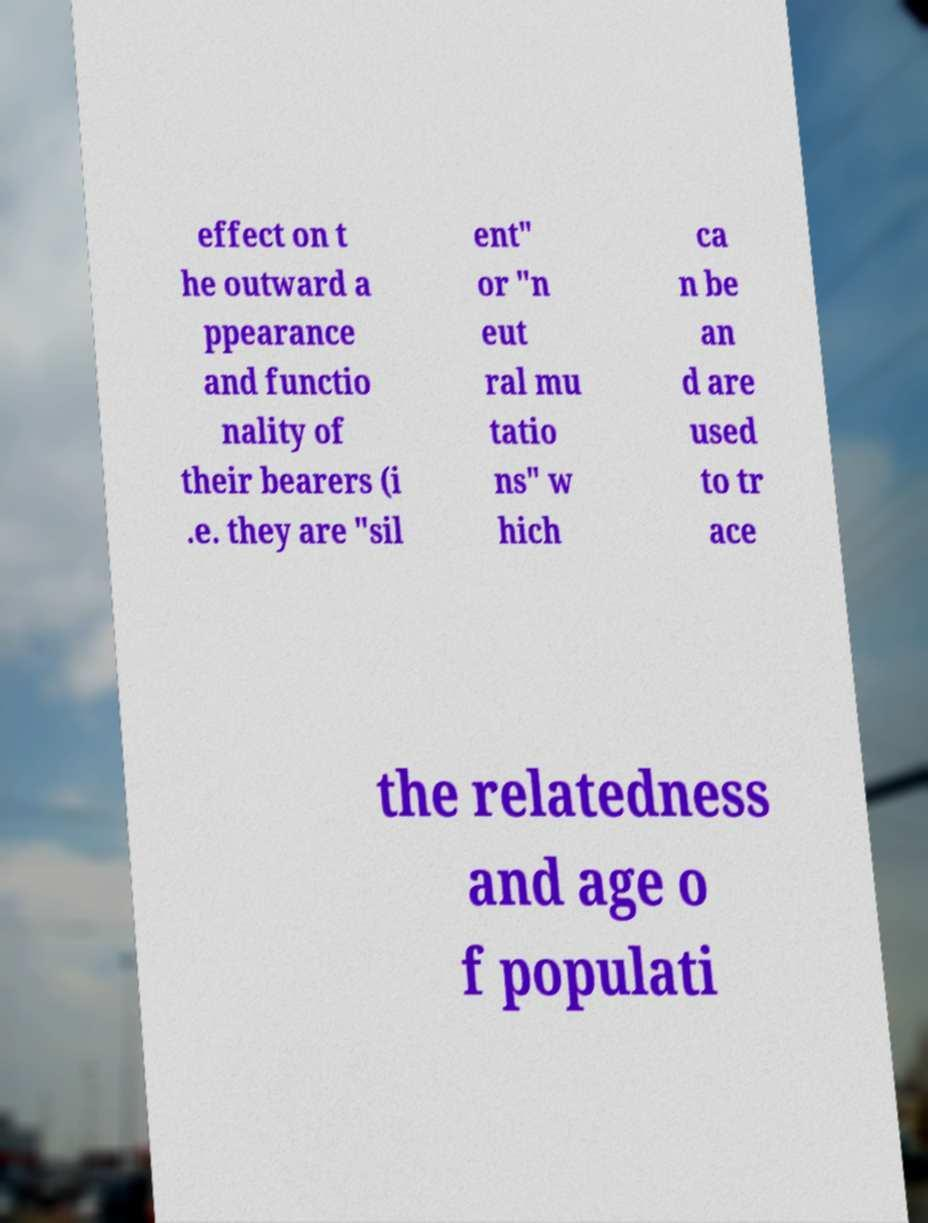Could you assist in decoding the text presented in this image and type it out clearly? effect on t he outward a ppearance and functio nality of their bearers (i .e. they are "sil ent" or "n eut ral mu tatio ns" w hich ca n be an d are used to tr ace the relatedness and age o f populati 